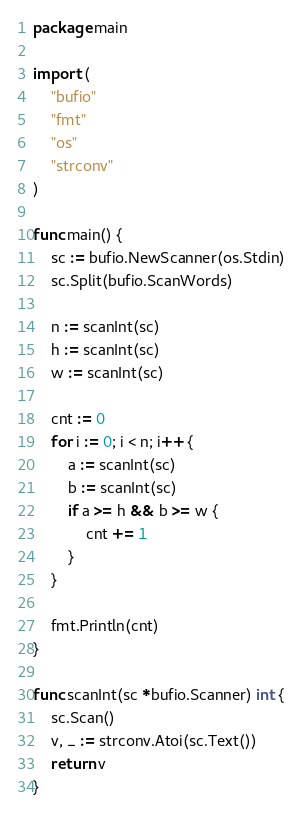<code> <loc_0><loc_0><loc_500><loc_500><_Go_>package main

import (
	"bufio"
	"fmt"
	"os"
	"strconv"
)

func main() {
	sc := bufio.NewScanner(os.Stdin)
	sc.Split(bufio.ScanWords)

	n := scanInt(sc)
	h := scanInt(sc)
	w := scanInt(sc)

	cnt := 0
	for i := 0; i < n; i++ {
		a := scanInt(sc)
		b := scanInt(sc)
		if a >= h && b >= w {
			cnt += 1
		}
	}

	fmt.Println(cnt)
}

func scanInt(sc *bufio.Scanner) int {
	sc.Scan()
	v, _ := strconv.Atoi(sc.Text())
	return v
}
</code> 